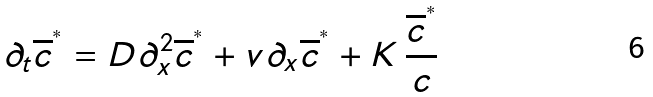<formula> <loc_0><loc_0><loc_500><loc_500>\partial _ { t } \overline { c } ^ { ^ { * } } = D \partial _ { x } ^ { 2 } \overline { c } ^ { ^ { * } } + v \partial _ { x } \overline { c } ^ { ^ { * } } + K \, \frac { \overline { c } ^ { ^ { * } } } { c }</formula> 